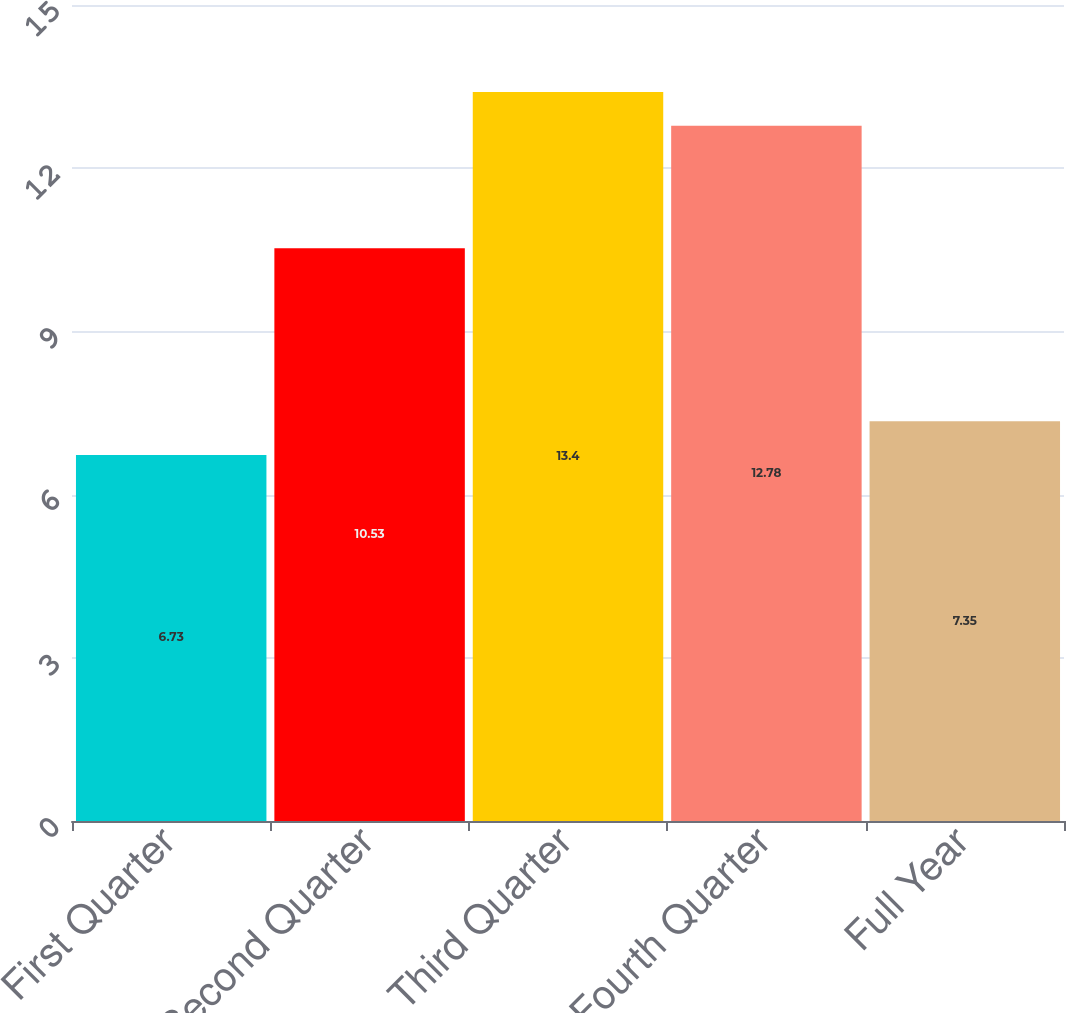Convert chart. <chart><loc_0><loc_0><loc_500><loc_500><bar_chart><fcel>First Quarter<fcel>Second Quarter<fcel>Third Quarter<fcel>Fourth Quarter<fcel>Full Year<nl><fcel>6.73<fcel>10.53<fcel>13.4<fcel>12.78<fcel>7.35<nl></chart> 